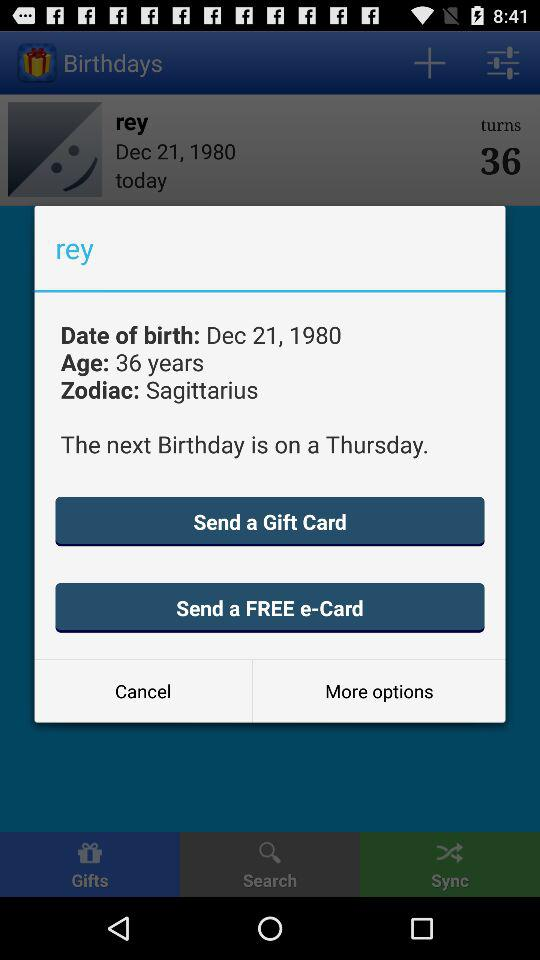On what day and date was Rey born? Rey was born on Thursday, December 21, 1980. 